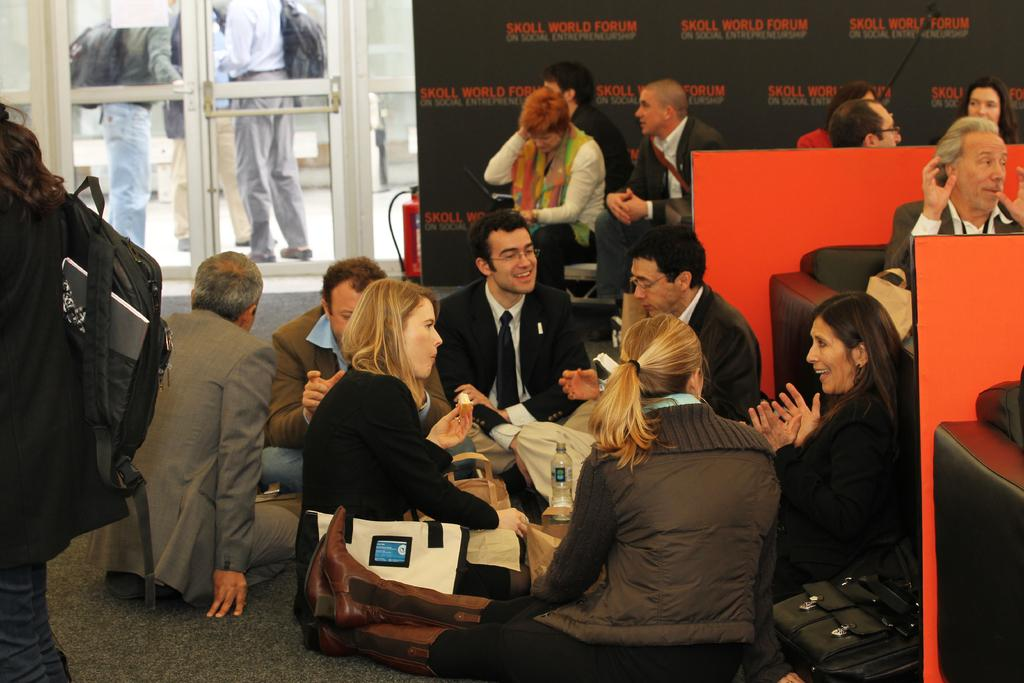What are the people in the image doing? There are people sitting in the image, and some people are standing behind a glass door. What items can be seen with the people in the image? There are bags and water bottles in the image. What type of door is present in the image? There is a glass door in the image. What are the people sitting wearing? The people sitting are wearing suits. Can you see a rat running around in the image? There is no rat present in the image. What type of ball is being used by the people in the image? There is no ball present in the image. 